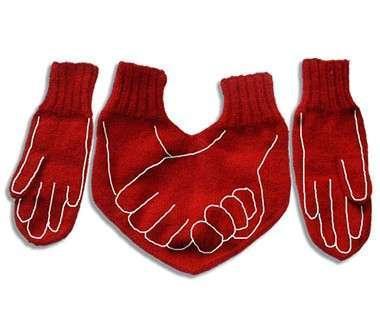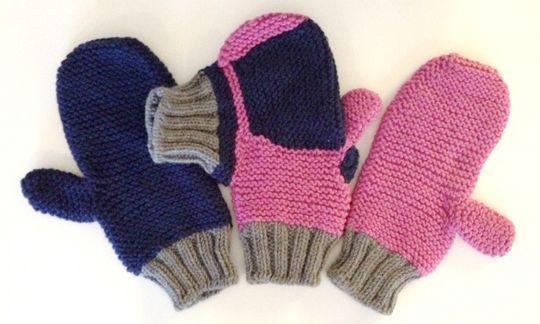The first image is the image on the left, the second image is the image on the right. Examine the images to the left and right. Is the description "All of the mittens in the image on the right are red." accurate? Answer yes or no. No. The first image is the image on the left, the second image is the image on the right. Given the left and right images, does the statement "The right image shows solid red mittens with a joined 'muff' between them." hold true? Answer yes or no. No. 